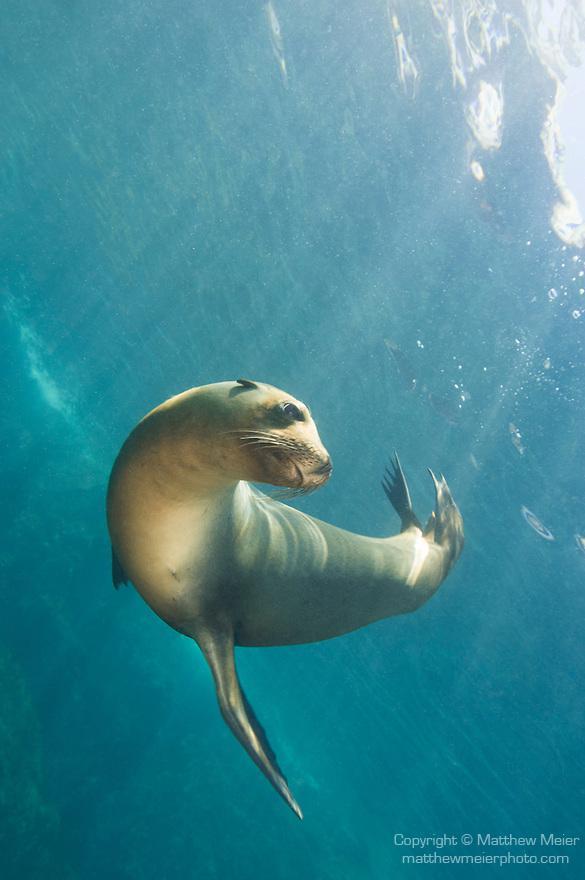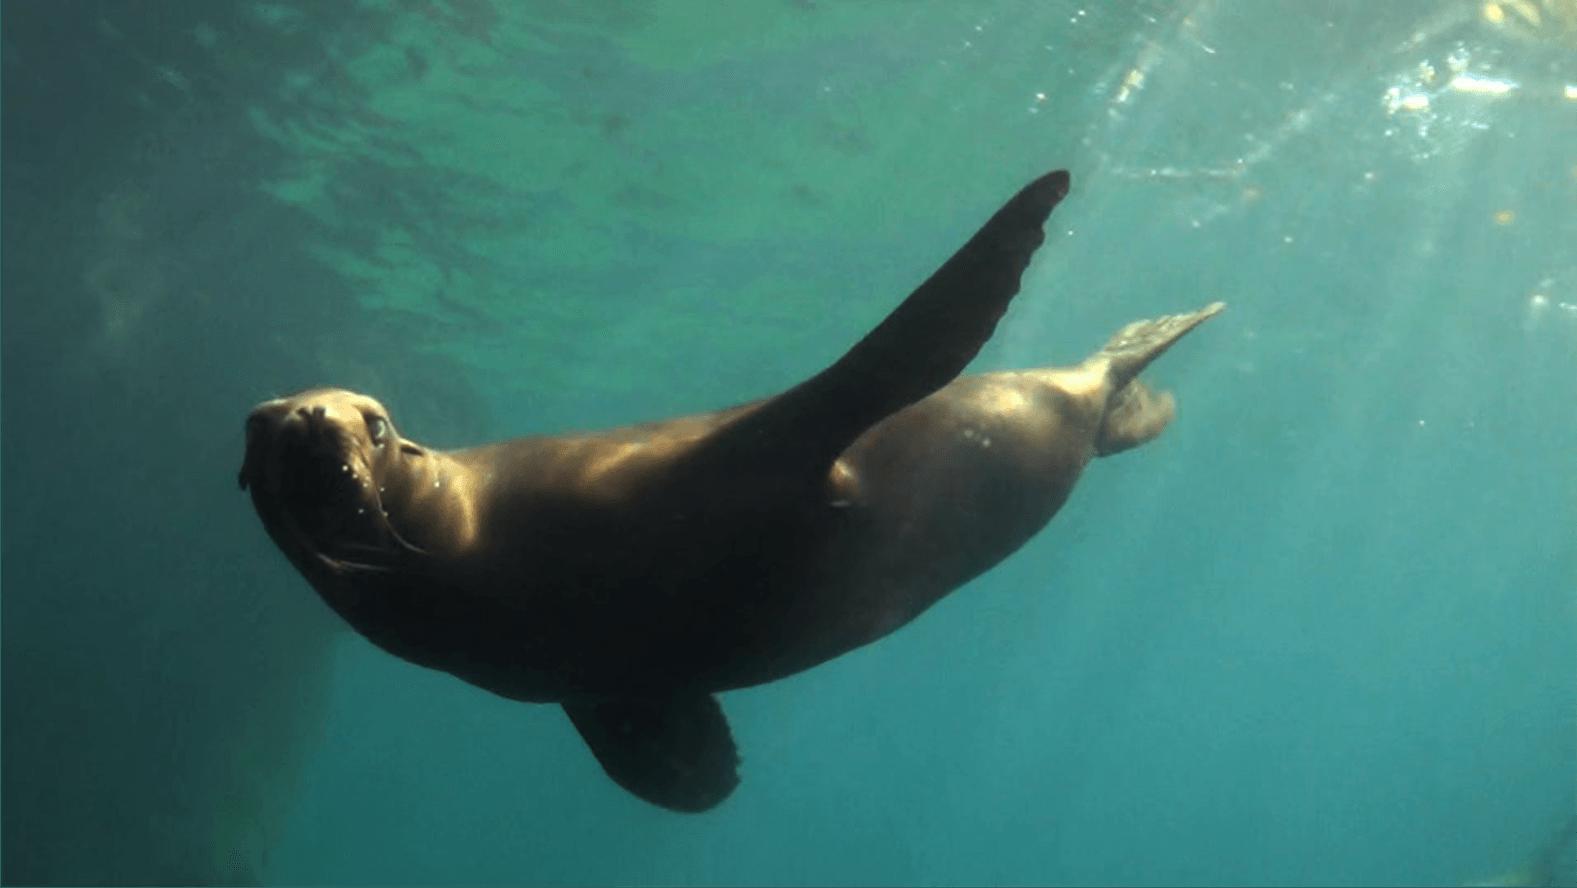The first image is the image on the left, the second image is the image on the right. Considering the images on both sides, is "One of the seals are swimming UP towards the surface." valid? Answer yes or no. No. The first image is the image on the left, the second image is the image on the right. For the images shown, is this caption "There are two seals swimming in the ocean." true? Answer yes or no. Yes. 